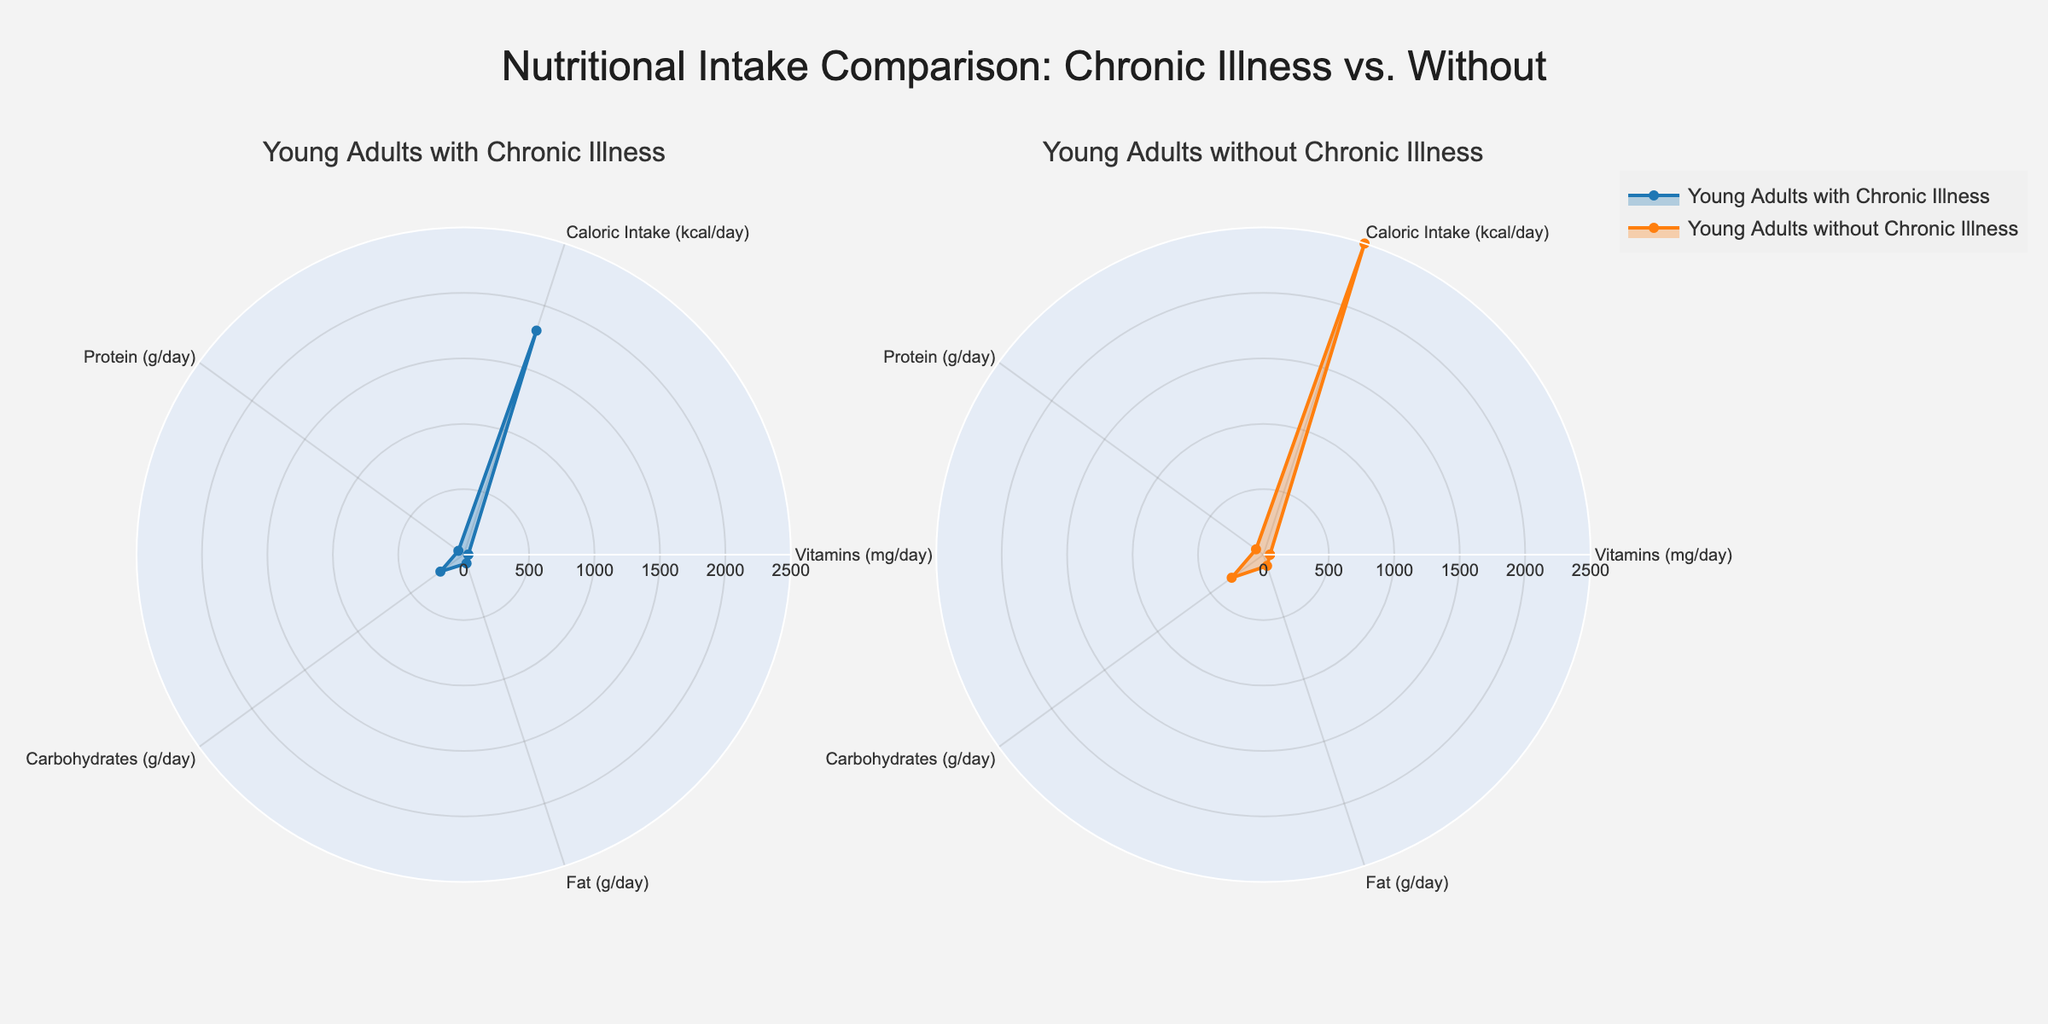What's the title of the plot? The title is "Nutritional Intake Comparison: Chronic Illness vs. Without". You can see it at the top center of the figure.
Answer: Nutritional Intake Comparison: Chronic Illness vs. Without Which group has a higher average caloric intake? The average caloric intake for Young Adults with Chronic Illness is 1800 kcal/day, and for Young Adults without Chronic Illness is 2500 kcal/day. Comparing these two values, the second group is higher.
Answer: Young Adults without Chronic Illness What is the caloric intake for Young Adults with Chronic Illness? In the radar chart under the subplot titled "Young Adults with Chronic Illness", the value for caloric intake is 1800 kcal/day.
Answer: 1800 kcal/day How much more protein do Young Adults without Chronic Illness consume compared to those with Chronic Illness? The protein intake for Young Adults without Chronic Illness is 70 g/day and for those with Chronic Illness is 50 g/day. The difference is 70 g/day - 50 g/day = 20 g/day.
Answer: 20 g/day Which nutrient shows the largest difference in intake between the two groups? The values for the nutrients are as follows:
- Vitamins (mg/day): 50 (without) vs 35 (with), difference = 15
- Caloric Intake (kcal/day): 2500 (without) vs 1800 (with), difference = 700
- Protein (g/day): 70 (without) vs 50 (with), difference = 20
- Carbohydrates (g/day): 300 (without) vs 220 (with), difference = 80
- Fat (g/day): 90 (without) vs 70 (with), difference = 20
The largest difference is in Caloric Intake, with a difference of 700 kcal/day.
Answer: Caloric Intake Which group has a higher intake of carbohydrates? The group titled "Young Adults without Chronic Illness" has a carbohydrate intake of 300 g/day, while those with Chronic Illness have 220 g/day. The former is higher.
Answer: Young Adults without Chronic Illness What is the range of the radial axis in the polar plots? The radial axis range is from 0 to 2500, which can be inferred from the radii of the plot and the points represented.
Answer: 0 to 2500 How does the vitamin intake of Young Adults with Chronic Illness compare to those without? The vitamin intake for Young Adults with Chronic Illness is 35 mg/day, and for those without it is 50 mg/day. The latter has a higher intake by 15 mg/day.
Answer: 15 mg/day less Which nutrient is least consumed by both groups? By observing the values plotted for each nutrient, "Vitamins (mg/day)" shows the lowest values for both groups: 35 mg/day for those with Chronic Illness and 50 mg/day for those without Chronic Illness.
Answer: Vitamins What color is used to represent the group with Chronic Illness? In the figure, the group with Chronic Illness is represented by a blue color for the line and light blue for the fill.
Answer: Blue 